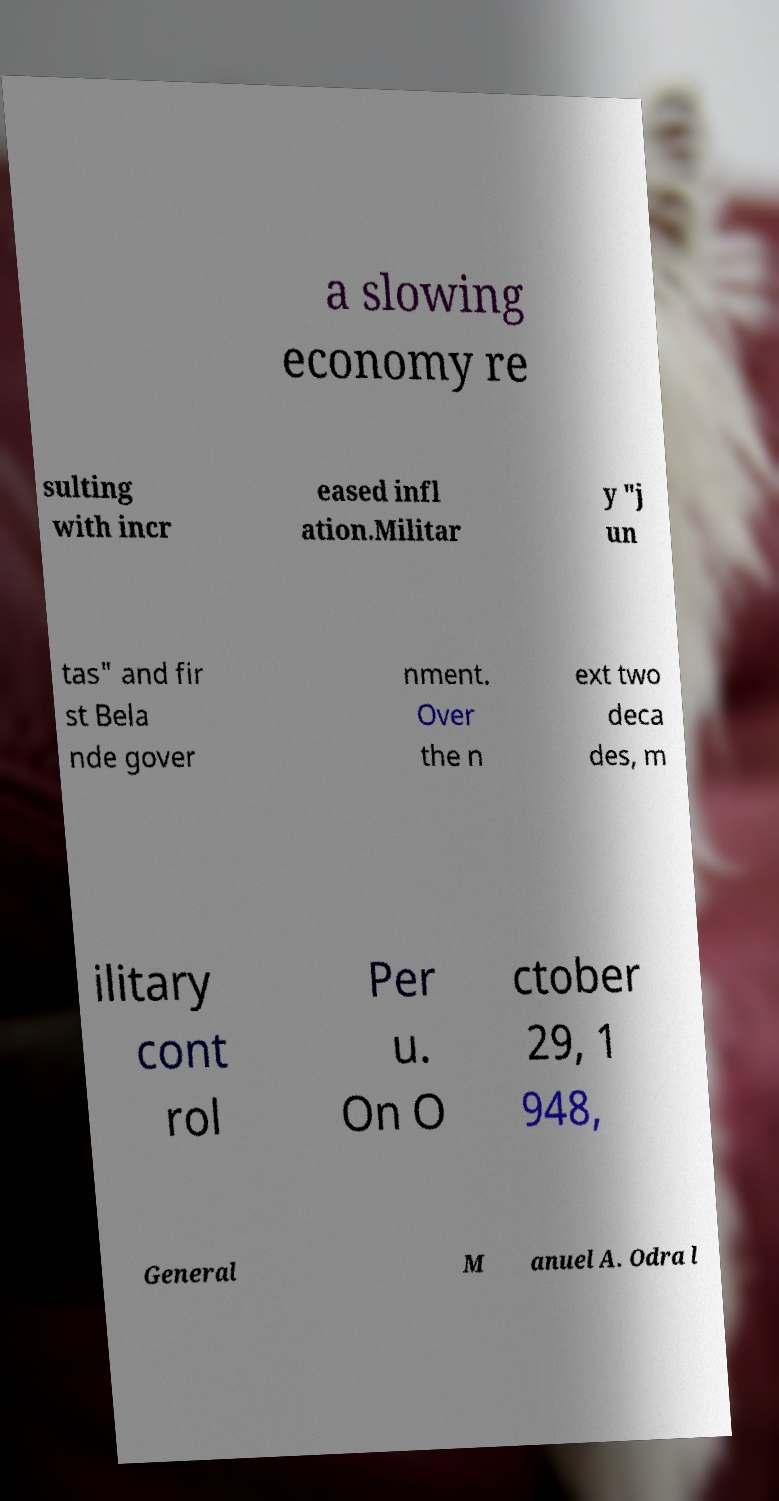Please read and relay the text visible in this image. What does it say? a slowing economy re sulting with incr eased infl ation.Militar y "j un tas" and fir st Bela nde gover nment. Over the n ext two deca des, m ilitary cont rol Per u. On O ctober 29, 1 948, General M anuel A. Odra l 